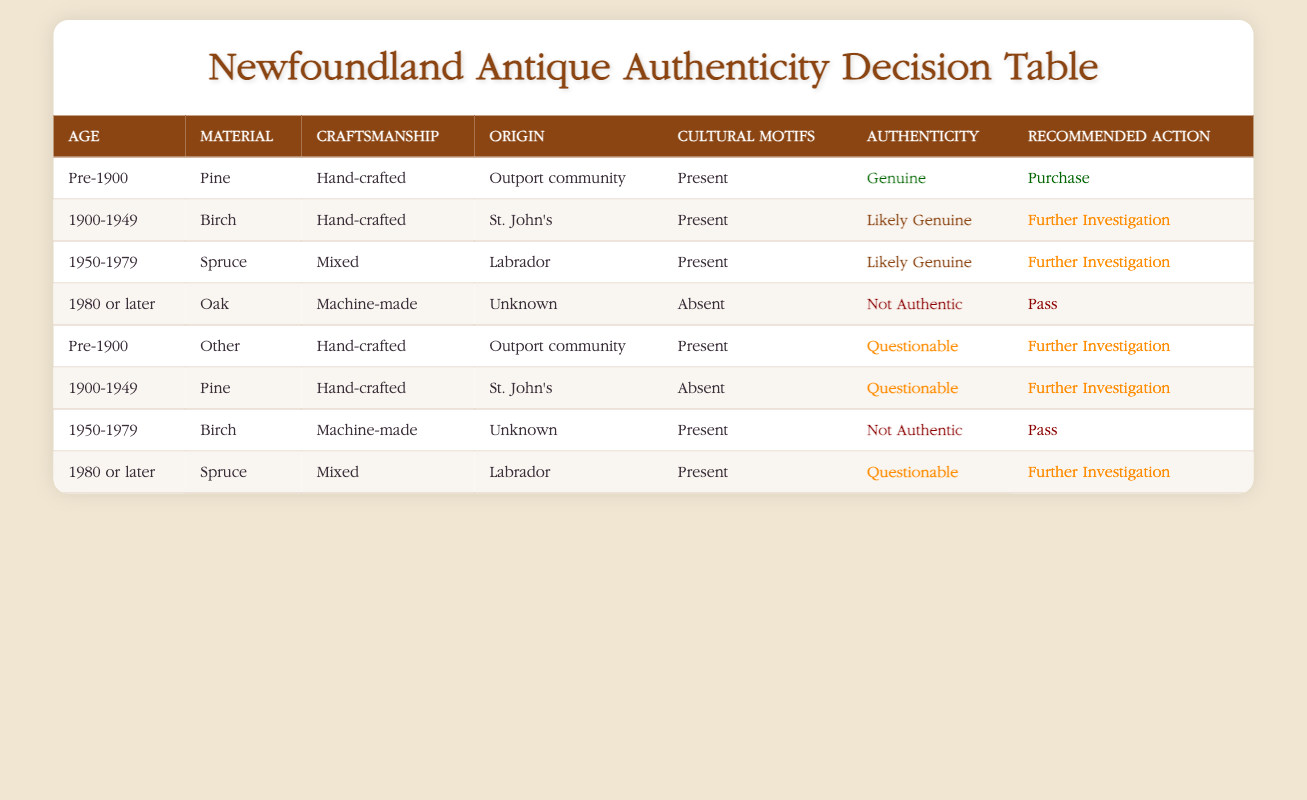What is the authenticity of a Pre-1900, Pine, Hand-crafted antique from an Outport community with Cultural Motifs present? According to the table, a Pre-1900 antique made of Pine, Hand-crafted, from an Outport community, and having Cultural Motifs present is classified as "Genuine".
Answer: Genuine How many antiques listed have a "Likely Genuine" authenticity status? There are 2 entries in the table labeled as "Likely Genuine". One is from 1900-1949, made of Birch, Hand-crafted, from St. John's with Cultural Motifs present, and another from 1950-1979, made of Spruce, Mixed craftsmanship, from Labrador with Cultural Motifs present.
Answer: 2 Is a machine-made item from 1950-1979 manufactured with Birch and has Cultural Motifs present authentic? No, based on the table, a machine-made item from that period with Birch and Cultural Motifs present is classified as "Not Authentic".
Answer: No What is the recommended action for a Pre-1900, Other material, Hand-crafted antique from an Outport community with Cultural Motifs present? The row for this condition shows that the recommended action is "Further Investigation" and the authenticity is categorized as "Questionable".
Answer: Further Investigation Which age category has the most items classified as "Not Authentic"? There are a total of 2 entries classified as "Not Authentic", both from 1980 or later, one made of Oak and another made of Birch. Specifically, these antiques feature machine-made craftsmanship and lack Cultural Motifs.
Answer: 1980 or later How many of the antiques listed are from St. John's? The table lists 2 antiques from St. John's: one from 1900-1949 made of Birch and hand-crafted with Cultural Motifs present, and another 1900-1949 made of Pine, hand-crafted but without Cultural Motifs.
Answer: 2 If an antique is from Labrador and is considered "Questionable", what is its age range? The rows indicated that an antique from Labrador holds the "Questionable" status only if it is 1980 or later and made of Spruce with Cultural Motifs present.
Answer: 1980 or later What type of material and craftsmanship leads to a "Not Authentic" status for an item from 1980 or later? The table specifies that an item from that time frame must be made of Oak and be machine-made to receive a "Not Authentic" classification.
Answer: Oak, Machine-made 